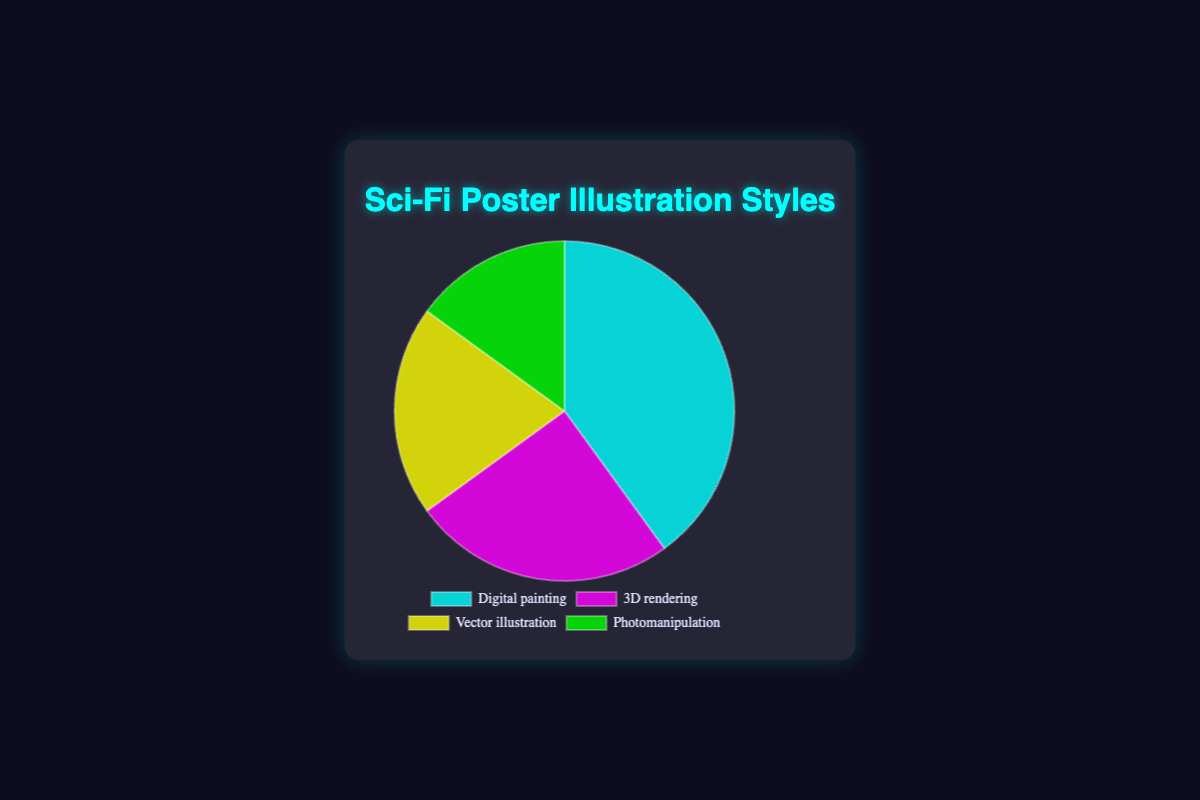What's the most used illustration style in Sci-Fi posters? The pie chart shows that the largest segment, representing 40%, corresponds to Digital painting, making it the most used style.
Answer: Digital painting Which illustration style is the second least used? The pie chart shows that Photomanipulation has 15%, which is the least used. The next smallest segment, at 20%, is Vector illustration.
Answer: Vector illustration What is the visual color representation of the 3D rendering style? The pie chart showcases different colors for the styles. The segment for 3D rendering is colored magenta.
Answer: Magenta Is the percentage of Digital painting more than double of Photomanipulation? Digital painting is 40% and Photomanipulation is 15%. Doubling Photomanipulation is 30%, which is less than Digital painting’s 40%.
Answer: Yes Which illustration styles combined make up a majority of the Sci-Fi poster styles? The combined percentage of Digital painting and 3D rendering is 40% + 25% = 65%, which is more than half.
Answer: Digital painting and 3D rendering How much more percentage is Digital painting than Vector illustration? Digital painting has 40% while Vector illustration has 20%. Therefore, the difference is 40% - 20% = 20%.
Answer: 20% What percentage of Sci-Fi posters do not use Digital painting? Since Digital painting is 40%, the rest is 100% - 40% = 60%.
Answer: 60% What is the sum of the percentages of Vector illustration and Photomanipulation? Vector illustration is 20% and Photomanipulation is 15%. The sum is 20% + 15% = 35%.
Answer: 35% How does the usage of 3D rendering compare to Photomanipulation in percentage? 3D rendering is 25% and Photomanipulation is 15%. 3D rendering usage is 10% more.
Answer: 10% more 